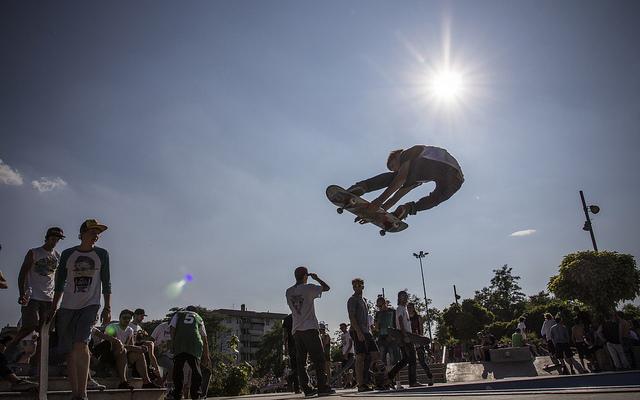What is in the air?
Short answer required. Person. Is the position of the skateboarder's legs reminiscent of an item that attracts iron filings?
Give a very brief answer. Yes. Is the boy skateboarding in a historical building?
Quick response, please. No. Is there a tree in the picture?
Quick response, please. Yes. What are the objects in the air?
Short answer required. People. Is this man holding his skateboard?
Write a very short answer. Yes. Is it foggy?
Concise answer only. No. How high did the skateboarder jump?
Concise answer only. High. What is projecting light on the men?
Quick response, please. Sun. What is causing the glare?
Be succinct. Sun. 